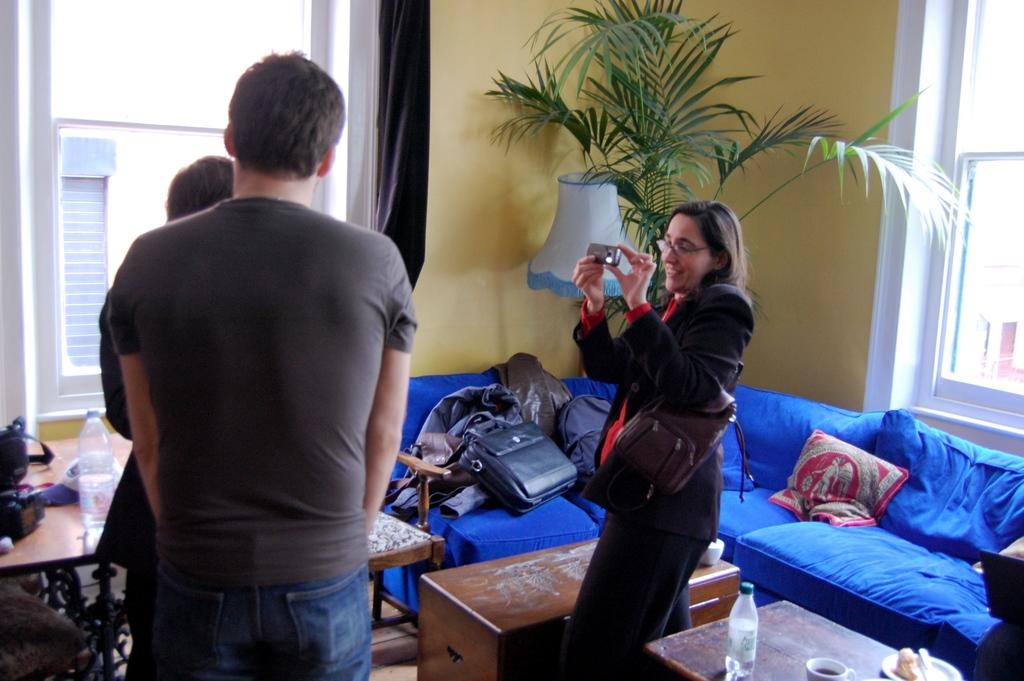How many people are in the image? There are people in the image, but the exact number is not specified. What is the woman holding in her hand? The woman is holding a camera in her hand. What else is the woman carrying? The woman is carrying a bag. What can be seen in the background of the image? There is a lamp and a plant in the background of the image. Can you see a ladybug crawling on the plant in the image? There is no mention of a ladybug in the image, so it cannot be confirmed if one is present or not. 